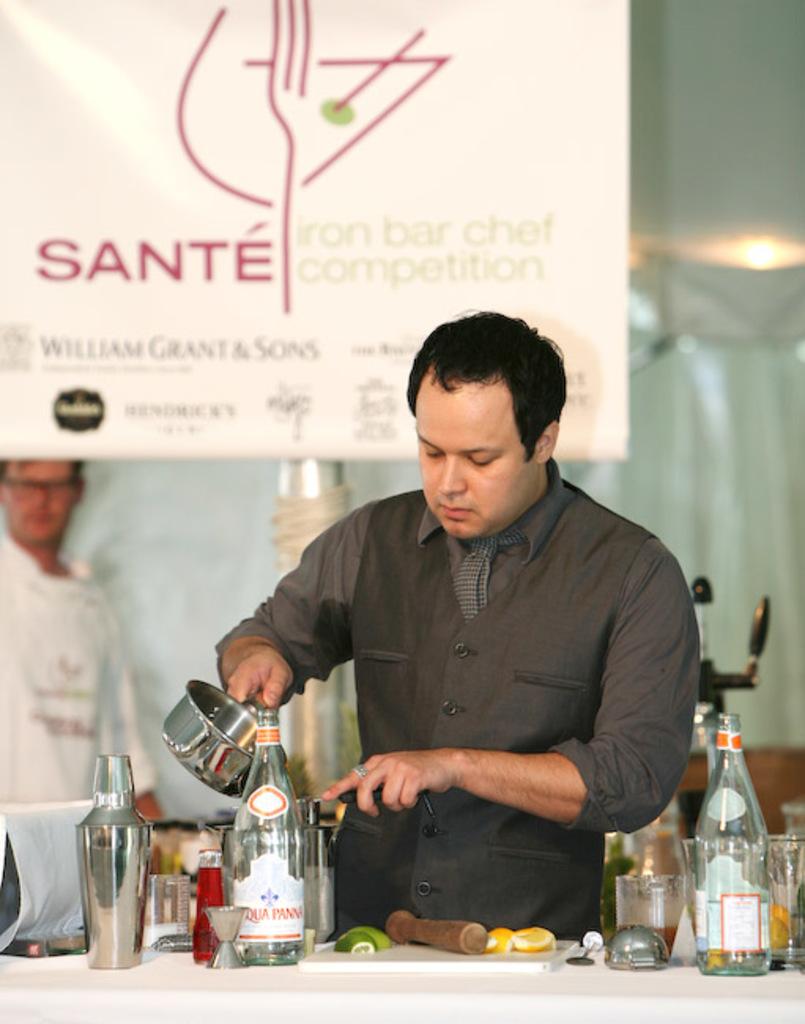What kind of competition is it?
Provide a succinct answer. Iron bar chef. Who is hosting this event?
Make the answer very short. Sante. 